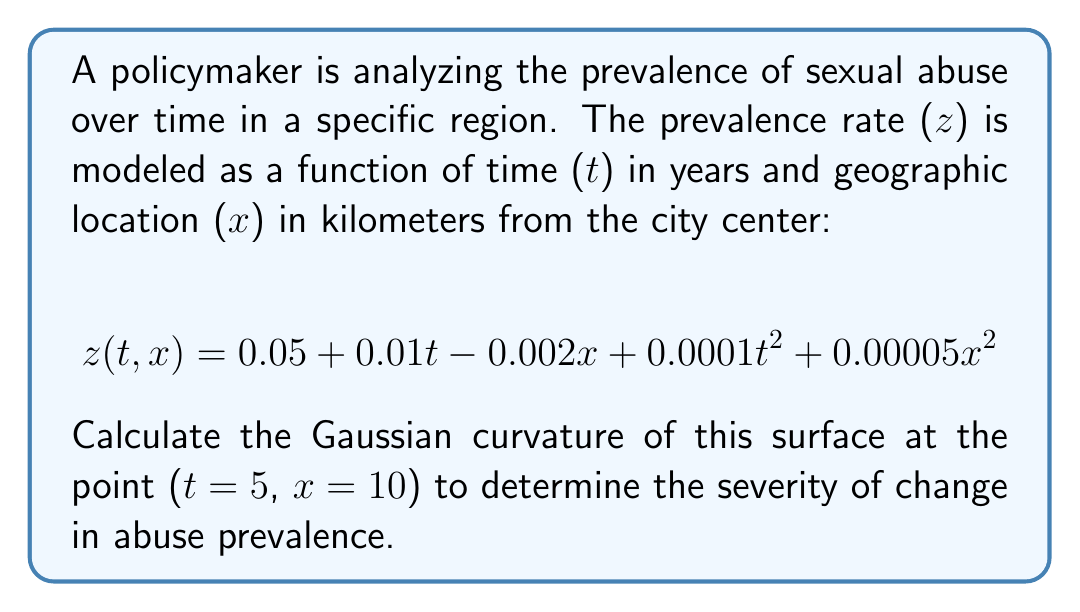Solve this math problem. To calculate the Gaussian curvature of the surface, we need to follow these steps:

1) The Gaussian curvature K is given by:
   $$K = \frac{LN - M^2}{EG - F^2}$$
   where L, M, N are coefficients of the second fundamental form, and E, F, G are coefficients of the first fundamental form.

2) First, we need to calculate the partial derivatives:
   $$z_t = 0.01 + 0.0002t$$
   $$z_x = -0.002 + 0.0001x$$
   $$z_{tt} = 0.0002$$
   $$z_{xx} = 0.0001$$
   $$z_{tx} = 0$$

3) Now we can calculate E, F, G:
   $$E = 1 + z_t^2 = 1 + (0.01 + 0.0002t)^2$$
   $$F = z_t z_x = (0.01 + 0.0002t)(-0.002 + 0.0001x)$$
   $$G = 1 + z_x^2 = 1 + (-0.002 + 0.0001x)^2$$

4) And L, M, N:
   $$L = \frac{z_{tt}}{\sqrt{1 + z_t^2 + z_x^2}} = \frac{0.0002}{\sqrt{1 + (0.01 + 0.0002t)^2 + (-0.002 + 0.0001x)^2}}$$
   $$M = \frac{z_{tx}}{\sqrt{1 + z_t^2 + z_x^2}} = 0$$
   $$N = \frac{z_{xx}}{\sqrt{1 + z_t^2 + z_x^2}} = \frac{0.0001}{\sqrt{1 + (0.01 + 0.0002t)^2 + (-0.002 + 0.0001x)^2}}$$

5) At the point (t=5, x=10):
   $$E = 1 + (0.01 + 0.0002(5))^2 = 1.000144$$
   $$F = (0.01 + 0.0002(5))(-0.002 + 0.0001(10)) = -1.2 \times 10^{-5}$$
   $$G = 1 + (-0.002 + 0.0001(10))^2 = 1$$
   $$L = \frac{0.0002}{\sqrt{1 + (0.01 + 0.0002(5))^2 + (-0.002 + 0.0001(10))^2}} = 0.0002$$
   $$M = 0$$
   $$N = \frac{0.0001}{\sqrt{1 + (0.01 + 0.0002(5))^2 + (-0.002 + 0.0001(10))^2}} = 0.0001$$

6) Finally, we can calculate the Gaussian curvature:
   $$K = \frac{LN - M^2}{EG - F^2} = \frac{(0.0002)(0.0001) - 0^2}{(1.000144)(1) - (-1.2 \times 10^{-5})^2} = 1.99968 \times 10^{-8}$$
Answer: $1.99968 \times 10^{-8}$ 